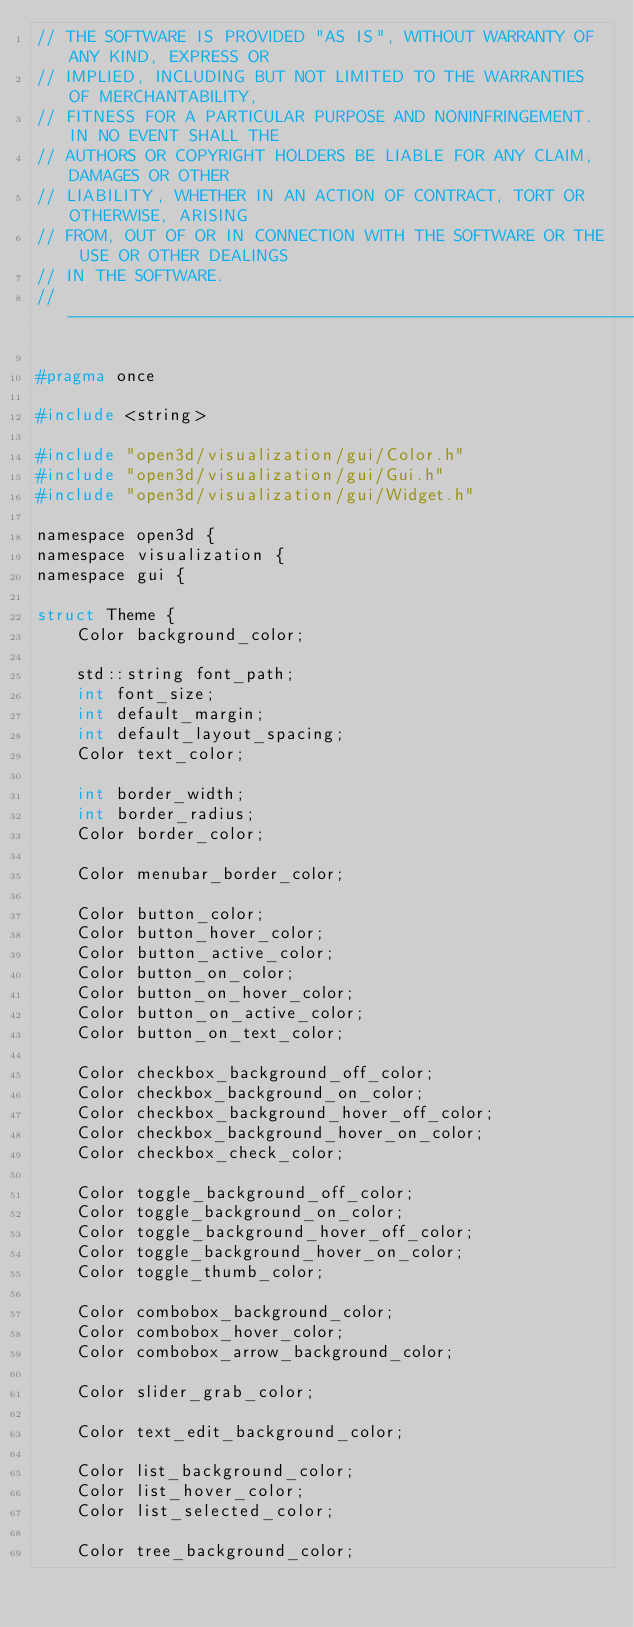<code> <loc_0><loc_0><loc_500><loc_500><_C_>// THE SOFTWARE IS PROVIDED "AS IS", WITHOUT WARRANTY OF ANY KIND, EXPRESS OR
// IMPLIED, INCLUDING BUT NOT LIMITED TO THE WARRANTIES OF MERCHANTABILITY,
// FITNESS FOR A PARTICULAR PURPOSE AND NONINFRINGEMENT. IN NO EVENT SHALL THE
// AUTHORS OR COPYRIGHT HOLDERS BE LIABLE FOR ANY CLAIM, DAMAGES OR OTHER
// LIABILITY, WHETHER IN AN ACTION OF CONTRACT, TORT OR OTHERWISE, ARISING
// FROM, OUT OF OR IN CONNECTION WITH THE SOFTWARE OR THE USE OR OTHER DEALINGS
// IN THE SOFTWARE.
// ----------------------------------------------------------------------------

#pragma once

#include <string>

#include "open3d/visualization/gui/Color.h"
#include "open3d/visualization/gui/Gui.h"
#include "open3d/visualization/gui/Widget.h"

namespace open3d {
namespace visualization {
namespace gui {

struct Theme {
    Color background_color;

    std::string font_path;
    int font_size;
    int default_margin;
    int default_layout_spacing;
    Color text_color;

    int border_width;
    int border_radius;
    Color border_color;

    Color menubar_border_color;

    Color button_color;
    Color button_hover_color;
    Color button_active_color;
    Color button_on_color;
    Color button_on_hover_color;
    Color button_on_active_color;
    Color button_on_text_color;

    Color checkbox_background_off_color;
    Color checkbox_background_on_color;
    Color checkbox_background_hover_off_color;
    Color checkbox_background_hover_on_color;
    Color checkbox_check_color;

    Color toggle_background_off_color;
    Color toggle_background_on_color;
    Color toggle_background_hover_off_color;
    Color toggle_background_hover_on_color;
    Color toggle_thumb_color;

    Color combobox_background_color;
    Color combobox_hover_color;
    Color combobox_arrow_background_color;

    Color slider_grab_color;

    Color text_edit_background_color;

    Color list_background_color;
    Color list_hover_color;
    Color list_selected_color;

    Color tree_background_color;</code> 